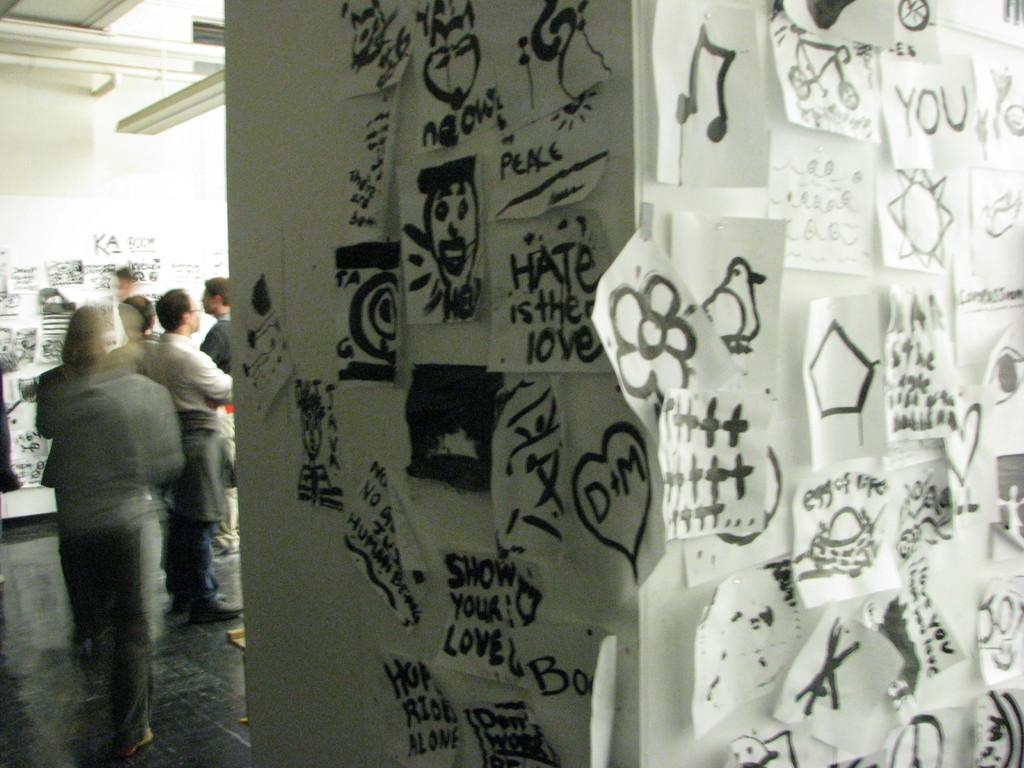What can be seen on the wall in the image? There are pictures pasted on the wall. What are the persons in the image doing? The persons are standing on the floor. What type of rock is being used as a doorstop in the image? There is no rock or doorstop present in the image. How many tickets can be seen in the hands of the persons in the image? There is no mention of tickets in the image; only pictures on the wall and persons standing on the floor are described. 